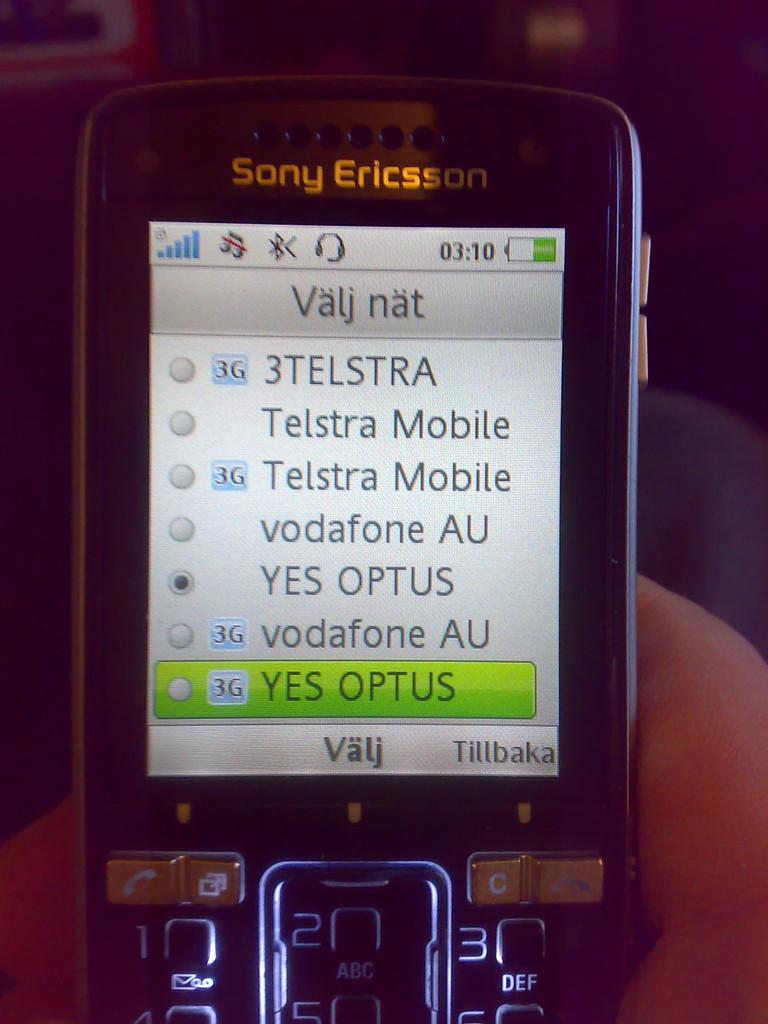Provide a one-sentence caption for the provided image. A picture of a Suny Ericsson phone and the word Valj at the bottom. 